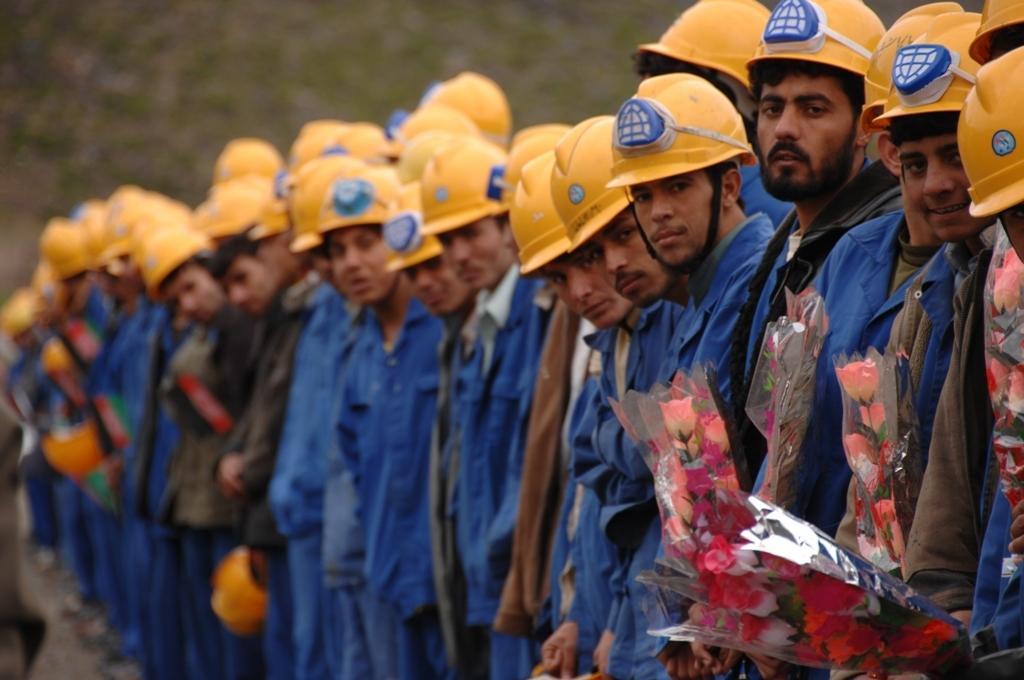Could you give a brief overview of what you see in this image? In this image there are workers who are wearing the blue shirt are standing side by side by wearing the helmets 